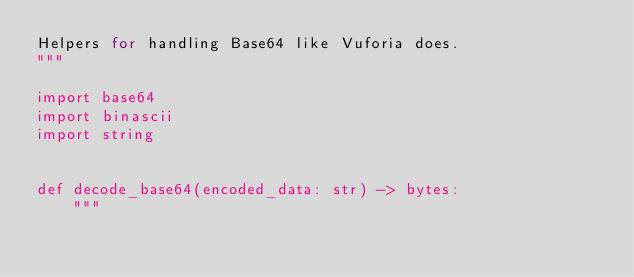<code> <loc_0><loc_0><loc_500><loc_500><_Python_>Helpers for handling Base64 like Vuforia does.
"""

import base64
import binascii
import string


def decode_base64(encoded_data: str) -> bytes:
    """</code> 